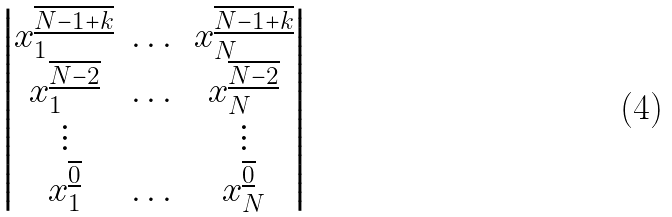<formula> <loc_0><loc_0><loc_500><loc_500>\begin{vmatrix} x _ { 1 } ^ { \overline { \underline { N - 1 + k } } } & \dots & x _ { N } ^ { \overline { \underline { N - 1 + k } } } \\ x _ { 1 } ^ { \overline { \underline { N - 2 } } } & \dots & x _ { N } ^ { \overline { \underline { N - 2 } } } \\ \vdots & & \vdots \\ x _ { 1 } ^ { \overline { \underline { 0 } } } & \dots & x _ { N } ^ { \overline { \underline { 0 } } } \end{vmatrix}</formula> 